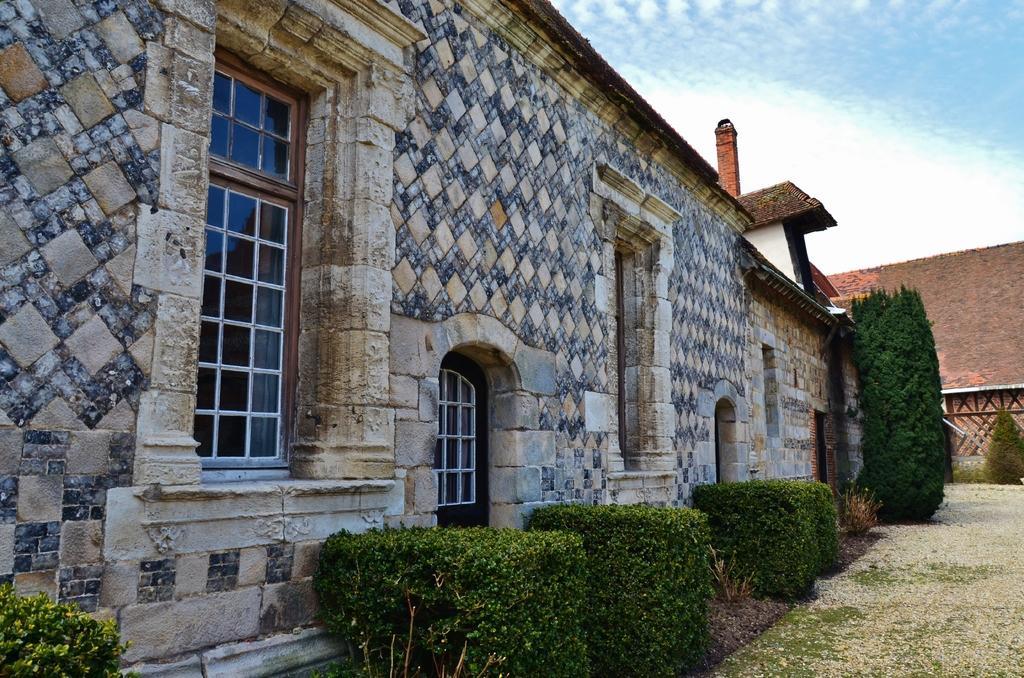Could you give a brief overview of what you see in this image? In this picture there is a building. In the foreground there are plants. At the back it looks like a mountain. At the top there is sky and there are clouds. At the bottom there is grass on the ground. 